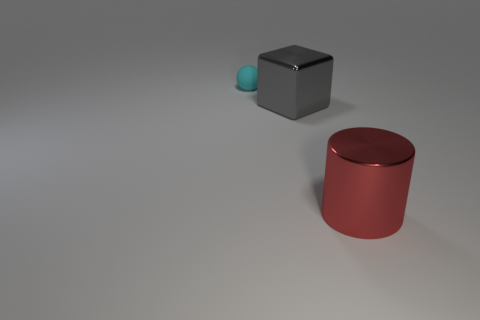If I wanted to recreate this scene, what mood should I aim for? To recreate the scene's mood, you would aim for a serene and contemplative atmosphere. The minimalist setup, combined with the soft lighting and neutral background, conveys a peaceful and clean aesthetic ideal for a study in form and color contrast. 